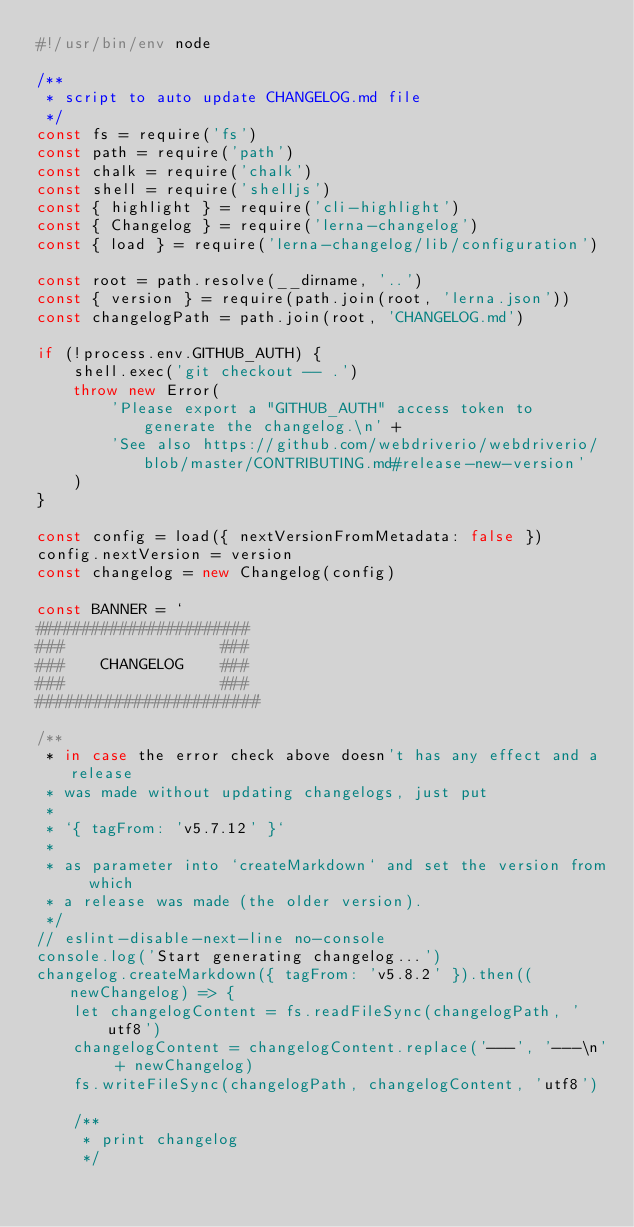Convert code to text. <code><loc_0><loc_0><loc_500><loc_500><_JavaScript_>#!/usr/bin/env node

/**
 * script to auto update CHANGELOG.md file
 */
const fs = require('fs')
const path = require('path')
const chalk = require('chalk')
const shell = require('shelljs')
const { highlight } = require('cli-highlight')
const { Changelog } = require('lerna-changelog')
const { load } = require('lerna-changelog/lib/configuration')

const root = path.resolve(__dirname, '..')
const { version } = require(path.join(root, 'lerna.json'))
const changelogPath = path.join(root, 'CHANGELOG.md')

if (!process.env.GITHUB_AUTH) {
    shell.exec('git checkout -- .')
    throw new Error(
        'Please export a "GITHUB_AUTH" access token to generate the changelog.\n' +
        'See also https://github.com/webdriverio/webdriverio/blob/master/CONTRIBUTING.md#release-new-version'
    )
}

const config = load({ nextVersionFromMetadata: false })
config.nextVersion = version
const changelog = new Changelog(config)

const BANNER = `
#######################
###                 ###
###    CHANGELOG    ###
###                 ###
#######################`

/**
 * in case the error check above doesn't has any effect and a release
 * was made without updating changelogs, just put
 *
 * `{ tagFrom: 'v5.7.12' }`
 *
 * as parameter into `createMarkdown` and set the version from which
 * a release was made (the older version).
 */
// eslint-disable-next-line no-console
console.log('Start generating changelog...')
changelog.createMarkdown({ tagFrom: 'v5.8.2' }).then((newChangelog) => {
    let changelogContent = fs.readFileSync(changelogPath, 'utf8')
    changelogContent = changelogContent.replace('---', '---\n' + newChangelog)
    fs.writeFileSync(changelogPath, changelogContent, 'utf8')

    /**
     * print changelog
     */</code> 